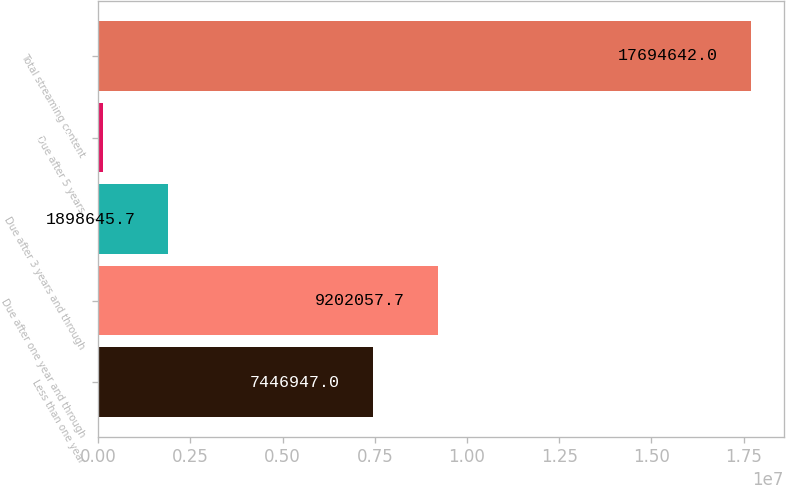<chart> <loc_0><loc_0><loc_500><loc_500><bar_chart><fcel>Less than one year<fcel>Due after one year and through<fcel>Due after 3 years and through<fcel>Due after 5 years<fcel>Total streaming content<nl><fcel>7.44695e+06<fcel>9.20206e+06<fcel>1.89865e+06<fcel>143535<fcel>1.76946e+07<nl></chart> 